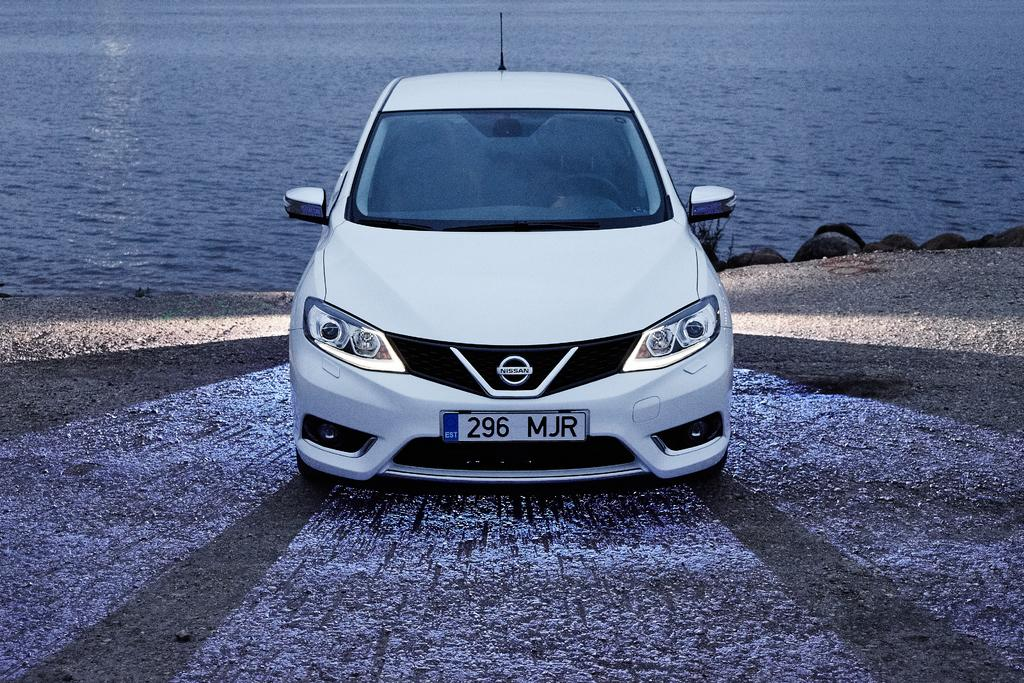What is the main subject of the image? The main subject of the image is a car. Where is the car located in the image? The car is on the road in the image. What can be seen in the background of the image? There is water and rocks visible in the background of the image. What is the opinion of the car about the water in the background? Cars do not have opinions, as they are inanimate objects. 